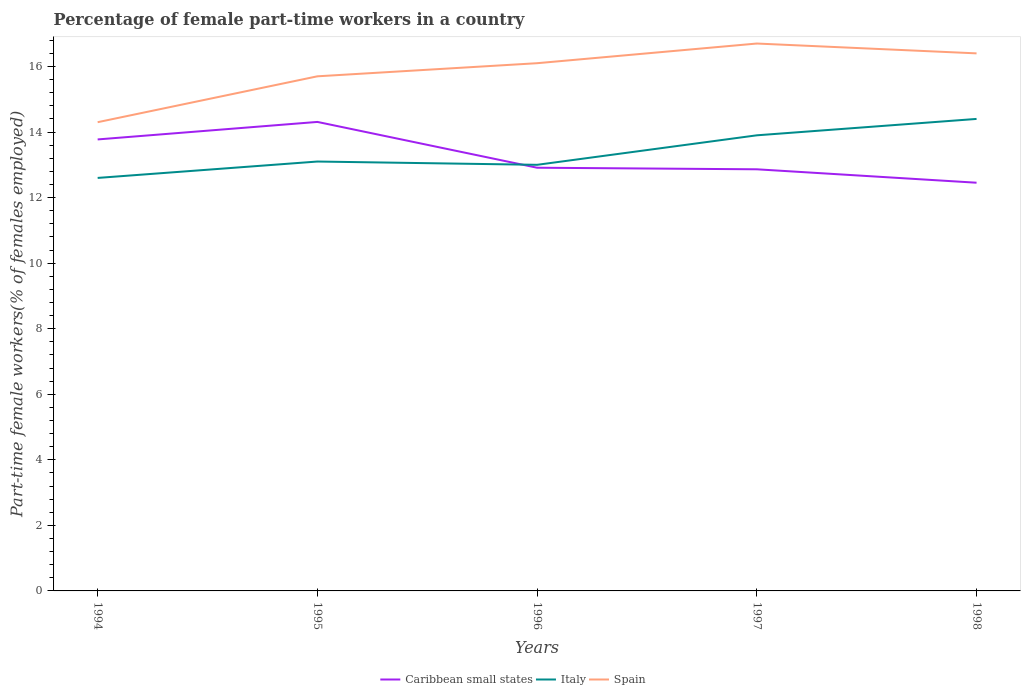How many different coloured lines are there?
Provide a short and direct response. 3. Does the line corresponding to Italy intersect with the line corresponding to Spain?
Your answer should be compact. No. Is the number of lines equal to the number of legend labels?
Your answer should be compact. Yes. Across all years, what is the maximum percentage of female part-time workers in Italy?
Your answer should be very brief. 12.6. What is the total percentage of female part-time workers in Caribbean small states in the graph?
Offer a very short reply. -0.53. What is the difference between the highest and the second highest percentage of female part-time workers in Caribbean small states?
Keep it short and to the point. 1.85. How many years are there in the graph?
Ensure brevity in your answer.  5. What is the difference between two consecutive major ticks on the Y-axis?
Ensure brevity in your answer.  2. Where does the legend appear in the graph?
Your response must be concise. Bottom center. How many legend labels are there?
Give a very brief answer. 3. How are the legend labels stacked?
Offer a terse response. Horizontal. What is the title of the graph?
Ensure brevity in your answer.  Percentage of female part-time workers in a country. Does "Aruba" appear as one of the legend labels in the graph?
Provide a succinct answer. No. What is the label or title of the X-axis?
Your answer should be very brief. Years. What is the label or title of the Y-axis?
Make the answer very short. Part-time female workers(% of females employed). What is the Part-time female workers(% of females employed) of Caribbean small states in 1994?
Your response must be concise. 13.77. What is the Part-time female workers(% of females employed) in Italy in 1994?
Offer a terse response. 12.6. What is the Part-time female workers(% of females employed) of Spain in 1994?
Your answer should be very brief. 14.3. What is the Part-time female workers(% of females employed) in Caribbean small states in 1995?
Your response must be concise. 14.31. What is the Part-time female workers(% of females employed) of Italy in 1995?
Make the answer very short. 13.1. What is the Part-time female workers(% of females employed) of Spain in 1995?
Offer a terse response. 15.7. What is the Part-time female workers(% of females employed) of Caribbean small states in 1996?
Provide a short and direct response. 12.91. What is the Part-time female workers(% of females employed) in Italy in 1996?
Your answer should be compact. 13. What is the Part-time female workers(% of females employed) in Spain in 1996?
Your answer should be compact. 16.1. What is the Part-time female workers(% of females employed) in Caribbean small states in 1997?
Give a very brief answer. 12.86. What is the Part-time female workers(% of females employed) of Italy in 1997?
Make the answer very short. 13.9. What is the Part-time female workers(% of females employed) in Spain in 1997?
Give a very brief answer. 16.7. What is the Part-time female workers(% of females employed) of Caribbean small states in 1998?
Ensure brevity in your answer.  12.45. What is the Part-time female workers(% of females employed) in Italy in 1998?
Keep it short and to the point. 14.4. What is the Part-time female workers(% of females employed) in Spain in 1998?
Your answer should be very brief. 16.4. Across all years, what is the maximum Part-time female workers(% of females employed) in Caribbean small states?
Your response must be concise. 14.31. Across all years, what is the maximum Part-time female workers(% of females employed) in Italy?
Your answer should be compact. 14.4. Across all years, what is the maximum Part-time female workers(% of females employed) in Spain?
Keep it short and to the point. 16.7. Across all years, what is the minimum Part-time female workers(% of females employed) of Caribbean small states?
Your response must be concise. 12.45. Across all years, what is the minimum Part-time female workers(% of females employed) of Italy?
Give a very brief answer. 12.6. Across all years, what is the minimum Part-time female workers(% of females employed) in Spain?
Keep it short and to the point. 14.3. What is the total Part-time female workers(% of females employed) of Caribbean small states in the graph?
Your answer should be compact. 66.31. What is the total Part-time female workers(% of females employed) in Italy in the graph?
Your answer should be compact. 67. What is the total Part-time female workers(% of females employed) of Spain in the graph?
Ensure brevity in your answer.  79.2. What is the difference between the Part-time female workers(% of females employed) in Caribbean small states in 1994 and that in 1995?
Your response must be concise. -0.53. What is the difference between the Part-time female workers(% of females employed) in Caribbean small states in 1994 and that in 1996?
Give a very brief answer. 0.86. What is the difference between the Part-time female workers(% of females employed) of Italy in 1994 and that in 1996?
Provide a succinct answer. -0.4. What is the difference between the Part-time female workers(% of females employed) in Caribbean small states in 1994 and that in 1997?
Provide a succinct answer. 0.91. What is the difference between the Part-time female workers(% of females employed) in Italy in 1994 and that in 1997?
Keep it short and to the point. -1.3. What is the difference between the Part-time female workers(% of females employed) of Spain in 1994 and that in 1997?
Make the answer very short. -2.4. What is the difference between the Part-time female workers(% of females employed) of Caribbean small states in 1994 and that in 1998?
Your answer should be very brief. 1.32. What is the difference between the Part-time female workers(% of females employed) in Italy in 1994 and that in 1998?
Give a very brief answer. -1.8. What is the difference between the Part-time female workers(% of females employed) in Caribbean small states in 1995 and that in 1996?
Ensure brevity in your answer.  1.4. What is the difference between the Part-time female workers(% of females employed) of Italy in 1995 and that in 1996?
Make the answer very short. 0.1. What is the difference between the Part-time female workers(% of females employed) of Spain in 1995 and that in 1996?
Give a very brief answer. -0.4. What is the difference between the Part-time female workers(% of females employed) in Caribbean small states in 1995 and that in 1997?
Ensure brevity in your answer.  1.45. What is the difference between the Part-time female workers(% of females employed) of Italy in 1995 and that in 1997?
Offer a very short reply. -0.8. What is the difference between the Part-time female workers(% of females employed) of Caribbean small states in 1995 and that in 1998?
Offer a very short reply. 1.85. What is the difference between the Part-time female workers(% of females employed) of Spain in 1995 and that in 1998?
Ensure brevity in your answer.  -0.7. What is the difference between the Part-time female workers(% of females employed) of Caribbean small states in 1996 and that in 1997?
Ensure brevity in your answer.  0.05. What is the difference between the Part-time female workers(% of females employed) of Italy in 1996 and that in 1997?
Provide a succinct answer. -0.9. What is the difference between the Part-time female workers(% of females employed) of Caribbean small states in 1996 and that in 1998?
Your response must be concise. 0.46. What is the difference between the Part-time female workers(% of females employed) in Spain in 1996 and that in 1998?
Offer a very short reply. -0.3. What is the difference between the Part-time female workers(% of females employed) of Caribbean small states in 1997 and that in 1998?
Your answer should be very brief. 0.41. What is the difference between the Part-time female workers(% of females employed) in Italy in 1997 and that in 1998?
Provide a short and direct response. -0.5. What is the difference between the Part-time female workers(% of females employed) in Spain in 1997 and that in 1998?
Provide a succinct answer. 0.3. What is the difference between the Part-time female workers(% of females employed) in Caribbean small states in 1994 and the Part-time female workers(% of females employed) in Italy in 1995?
Ensure brevity in your answer.  0.67. What is the difference between the Part-time female workers(% of females employed) in Caribbean small states in 1994 and the Part-time female workers(% of females employed) in Spain in 1995?
Offer a very short reply. -1.93. What is the difference between the Part-time female workers(% of females employed) in Caribbean small states in 1994 and the Part-time female workers(% of females employed) in Italy in 1996?
Give a very brief answer. 0.77. What is the difference between the Part-time female workers(% of females employed) of Caribbean small states in 1994 and the Part-time female workers(% of females employed) of Spain in 1996?
Give a very brief answer. -2.33. What is the difference between the Part-time female workers(% of females employed) of Italy in 1994 and the Part-time female workers(% of females employed) of Spain in 1996?
Your answer should be very brief. -3.5. What is the difference between the Part-time female workers(% of females employed) in Caribbean small states in 1994 and the Part-time female workers(% of females employed) in Italy in 1997?
Provide a succinct answer. -0.13. What is the difference between the Part-time female workers(% of females employed) of Caribbean small states in 1994 and the Part-time female workers(% of females employed) of Spain in 1997?
Keep it short and to the point. -2.93. What is the difference between the Part-time female workers(% of females employed) of Italy in 1994 and the Part-time female workers(% of females employed) of Spain in 1997?
Keep it short and to the point. -4.1. What is the difference between the Part-time female workers(% of females employed) in Caribbean small states in 1994 and the Part-time female workers(% of females employed) in Italy in 1998?
Provide a succinct answer. -0.63. What is the difference between the Part-time female workers(% of females employed) in Caribbean small states in 1994 and the Part-time female workers(% of females employed) in Spain in 1998?
Offer a terse response. -2.63. What is the difference between the Part-time female workers(% of females employed) in Caribbean small states in 1995 and the Part-time female workers(% of females employed) in Italy in 1996?
Provide a succinct answer. 1.31. What is the difference between the Part-time female workers(% of females employed) of Caribbean small states in 1995 and the Part-time female workers(% of females employed) of Spain in 1996?
Provide a short and direct response. -1.79. What is the difference between the Part-time female workers(% of females employed) of Caribbean small states in 1995 and the Part-time female workers(% of females employed) of Italy in 1997?
Ensure brevity in your answer.  0.41. What is the difference between the Part-time female workers(% of females employed) in Caribbean small states in 1995 and the Part-time female workers(% of females employed) in Spain in 1997?
Your answer should be very brief. -2.39. What is the difference between the Part-time female workers(% of females employed) in Caribbean small states in 1995 and the Part-time female workers(% of females employed) in Italy in 1998?
Make the answer very short. -0.09. What is the difference between the Part-time female workers(% of females employed) of Caribbean small states in 1995 and the Part-time female workers(% of females employed) of Spain in 1998?
Your answer should be very brief. -2.09. What is the difference between the Part-time female workers(% of females employed) in Italy in 1995 and the Part-time female workers(% of females employed) in Spain in 1998?
Your answer should be very brief. -3.3. What is the difference between the Part-time female workers(% of females employed) of Caribbean small states in 1996 and the Part-time female workers(% of females employed) of Italy in 1997?
Your answer should be very brief. -0.99. What is the difference between the Part-time female workers(% of females employed) of Caribbean small states in 1996 and the Part-time female workers(% of females employed) of Spain in 1997?
Provide a short and direct response. -3.79. What is the difference between the Part-time female workers(% of females employed) of Italy in 1996 and the Part-time female workers(% of females employed) of Spain in 1997?
Make the answer very short. -3.7. What is the difference between the Part-time female workers(% of females employed) in Caribbean small states in 1996 and the Part-time female workers(% of females employed) in Italy in 1998?
Make the answer very short. -1.49. What is the difference between the Part-time female workers(% of females employed) in Caribbean small states in 1996 and the Part-time female workers(% of females employed) in Spain in 1998?
Your response must be concise. -3.49. What is the difference between the Part-time female workers(% of females employed) in Italy in 1996 and the Part-time female workers(% of females employed) in Spain in 1998?
Give a very brief answer. -3.4. What is the difference between the Part-time female workers(% of females employed) of Caribbean small states in 1997 and the Part-time female workers(% of females employed) of Italy in 1998?
Offer a very short reply. -1.54. What is the difference between the Part-time female workers(% of females employed) of Caribbean small states in 1997 and the Part-time female workers(% of females employed) of Spain in 1998?
Your response must be concise. -3.54. What is the average Part-time female workers(% of females employed) of Caribbean small states per year?
Provide a short and direct response. 13.26. What is the average Part-time female workers(% of females employed) of Italy per year?
Make the answer very short. 13.4. What is the average Part-time female workers(% of females employed) of Spain per year?
Provide a short and direct response. 15.84. In the year 1994, what is the difference between the Part-time female workers(% of females employed) of Caribbean small states and Part-time female workers(% of females employed) of Italy?
Ensure brevity in your answer.  1.17. In the year 1994, what is the difference between the Part-time female workers(% of females employed) in Caribbean small states and Part-time female workers(% of females employed) in Spain?
Ensure brevity in your answer.  -0.53. In the year 1994, what is the difference between the Part-time female workers(% of females employed) in Italy and Part-time female workers(% of females employed) in Spain?
Your response must be concise. -1.7. In the year 1995, what is the difference between the Part-time female workers(% of females employed) in Caribbean small states and Part-time female workers(% of females employed) in Italy?
Ensure brevity in your answer.  1.21. In the year 1995, what is the difference between the Part-time female workers(% of females employed) in Caribbean small states and Part-time female workers(% of females employed) in Spain?
Offer a terse response. -1.39. In the year 1996, what is the difference between the Part-time female workers(% of females employed) of Caribbean small states and Part-time female workers(% of females employed) of Italy?
Offer a terse response. -0.09. In the year 1996, what is the difference between the Part-time female workers(% of females employed) of Caribbean small states and Part-time female workers(% of females employed) of Spain?
Provide a succinct answer. -3.19. In the year 1997, what is the difference between the Part-time female workers(% of females employed) of Caribbean small states and Part-time female workers(% of females employed) of Italy?
Your answer should be very brief. -1.04. In the year 1997, what is the difference between the Part-time female workers(% of females employed) in Caribbean small states and Part-time female workers(% of females employed) in Spain?
Your answer should be compact. -3.84. In the year 1998, what is the difference between the Part-time female workers(% of females employed) of Caribbean small states and Part-time female workers(% of females employed) of Italy?
Provide a succinct answer. -1.95. In the year 1998, what is the difference between the Part-time female workers(% of females employed) in Caribbean small states and Part-time female workers(% of females employed) in Spain?
Give a very brief answer. -3.95. In the year 1998, what is the difference between the Part-time female workers(% of females employed) in Italy and Part-time female workers(% of females employed) in Spain?
Provide a succinct answer. -2. What is the ratio of the Part-time female workers(% of females employed) in Caribbean small states in 1994 to that in 1995?
Give a very brief answer. 0.96. What is the ratio of the Part-time female workers(% of females employed) in Italy in 1994 to that in 1995?
Keep it short and to the point. 0.96. What is the ratio of the Part-time female workers(% of females employed) of Spain in 1994 to that in 1995?
Your answer should be very brief. 0.91. What is the ratio of the Part-time female workers(% of females employed) of Caribbean small states in 1994 to that in 1996?
Your response must be concise. 1.07. What is the ratio of the Part-time female workers(% of females employed) of Italy in 1994 to that in 1996?
Offer a very short reply. 0.97. What is the ratio of the Part-time female workers(% of females employed) in Spain in 1994 to that in 1996?
Make the answer very short. 0.89. What is the ratio of the Part-time female workers(% of females employed) of Caribbean small states in 1994 to that in 1997?
Offer a terse response. 1.07. What is the ratio of the Part-time female workers(% of females employed) in Italy in 1994 to that in 1997?
Your answer should be very brief. 0.91. What is the ratio of the Part-time female workers(% of females employed) of Spain in 1994 to that in 1997?
Offer a terse response. 0.86. What is the ratio of the Part-time female workers(% of females employed) of Caribbean small states in 1994 to that in 1998?
Your answer should be very brief. 1.11. What is the ratio of the Part-time female workers(% of females employed) of Italy in 1994 to that in 1998?
Your answer should be very brief. 0.88. What is the ratio of the Part-time female workers(% of females employed) of Spain in 1994 to that in 1998?
Your response must be concise. 0.87. What is the ratio of the Part-time female workers(% of females employed) of Caribbean small states in 1995 to that in 1996?
Keep it short and to the point. 1.11. What is the ratio of the Part-time female workers(% of females employed) of Italy in 1995 to that in 1996?
Provide a short and direct response. 1.01. What is the ratio of the Part-time female workers(% of females employed) in Spain in 1995 to that in 1996?
Your answer should be compact. 0.98. What is the ratio of the Part-time female workers(% of females employed) of Caribbean small states in 1995 to that in 1997?
Provide a short and direct response. 1.11. What is the ratio of the Part-time female workers(% of females employed) in Italy in 1995 to that in 1997?
Your answer should be compact. 0.94. What is the ratio of the Part-time female workers(% of females employed) of Spain in 1995 to that in 1997?
Offer a very short reply. 0.94. What is the ratio of the Part-time female workers(% of females employed) of Caribbean small states in 1995 to that in 1998?
Give a very brief answer. 1.15. What is the ratio of the Part-time female workers(% of females employed) in Italy in 1995 to that in 1998?
Keep it short and to the point. 0.91. What is the ratio of the Part-time female workers(% of females employed) of Spain in 1995 to that in 1998?
Offer a very short reply. 0.96. What is the ratio of the Part-time female workers(% of females employed) in Italy in 1996 to that in 1997?
Keep it short and to the point. 0.94. What is the ratio of the Part-time female workers(% of females employed) in Spain in 1996 to that in 1997?
Provide a succinct answer. 0.96. What is the ratio of the Part-time female workers(% of females employed) of Caribbean small states in 1996 to that in 1998?
Give a very brief answer. 1.04. What is the ratio of the Part-time female workers(% of females employed) in Italy in 1996 to that in 1998?
Make the answer very short. 0.9. What is the ratio of the Part-time female workers(% of females employed) in Spain in 1996 to that in 1998?
Make the answer very short. 0.98. What is the ratio of the Part-time female workers(% of females employed) of Caribbean small states in 1997 to that in 1998?
Offer a very short reply. 1.03. What is the ratio of the Part-time female workers(% of females employed) in Italy in 1997 to that in 1998?
Provide a short and direct response. 0.97. What is the ratio of the Part-time female workers(% of females employed) of Spain in 1997 to that in 1998?
Make the answer very short. 1.02. What is the difference between the highest and the second highest Part-time female workers(% of females employed) in Caribbean small states?
Give a very brief answer. 0.53. What is the difference between the highest and the second highest Part-time female workers(% of females employed) in Italy?
Ensure brevity in your answer.  0.5. What is the difference between the highest and the second highest Part-time female workers(% of females employed) in Spain?
Keep it short and to the point. 0.3. What is the difference between the highest and the lowest Part-time female workers(% of females employed) of Caribbean small states?
Give a very brief answer. 1.85. What is the difference between the highest and the lowest Part-time female workers(% of females employed) of Spain?
Provide a short and direct response. 2.4. 